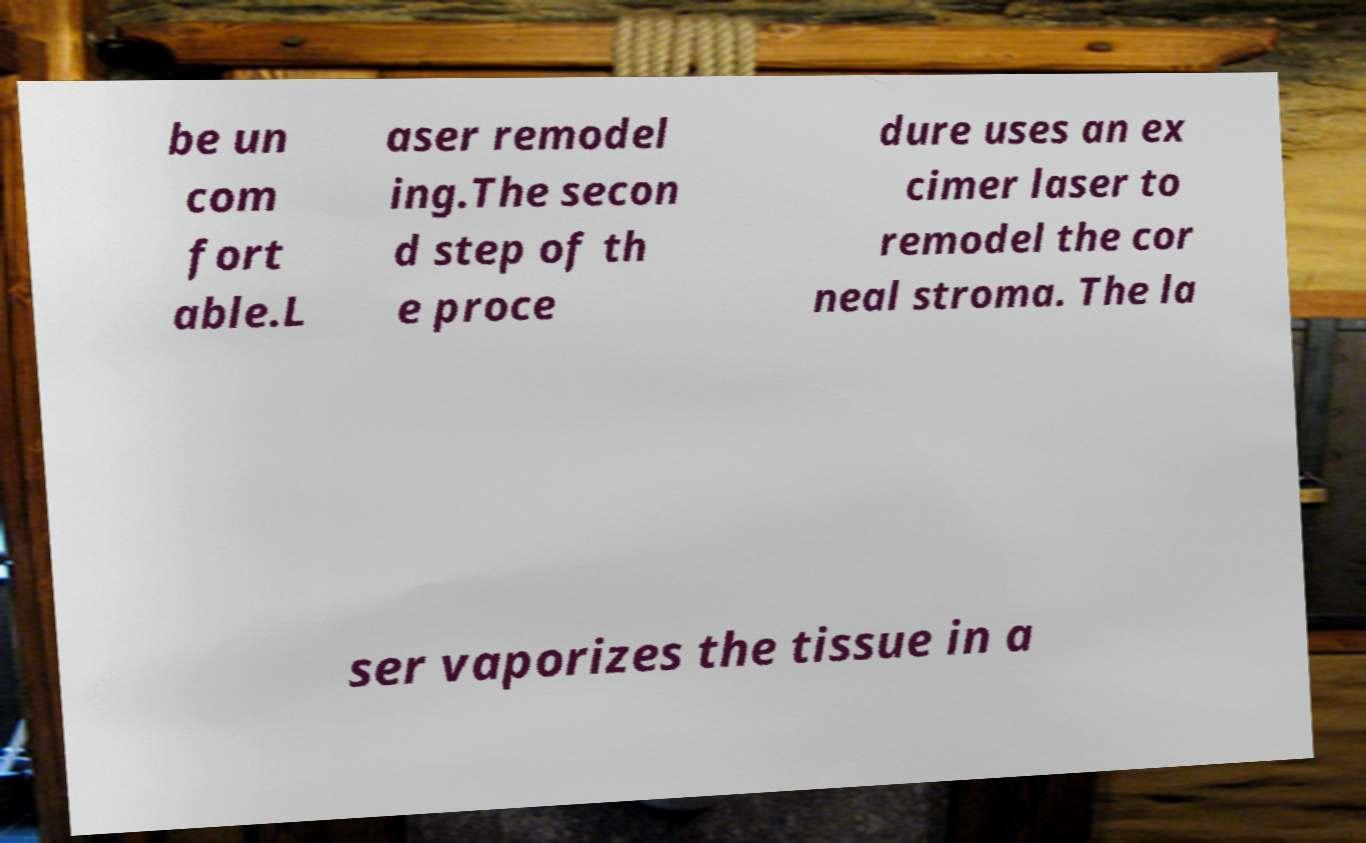I need the written content from this picture converted into text. Can you do that? be un com fort able.L aser remodel ing.The secon d step of th e proce dure uses an ex cimer laser to remodel the cor neal stroma. The la ser vaporizes the tissue in a 